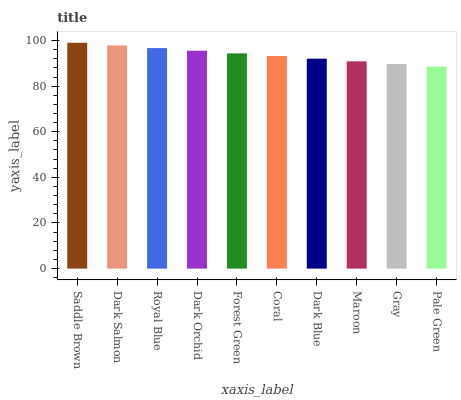Is Pale Green the minimum?
Answer yes or no. Yes. Is Saddle Brown the maximum?
Answer yes or no. Yes. Is Dark Salmon the minimum?
Answer yes or no. No. Is Dark Salmon the maximum?
Answer yes or no. No. Is Saddle Brown greater than Dark Salmon?
Answer yes or no. Yes. Is Dark Salmon less than Saddle Brown?
Answer yes or no. Yes. Is Dark Salmon greater than Saddle Brown?
Answer yes or no. No. Is Saddle Brown less than Dark Salmon?
Answer yes or no. No. Is Forest Green the high median?
Answer yes or no. Yes. Is Coral the low median?
Answer yes or no. Yes. Is Royal Blue the high median?
Answer yes or no. No. Is Royal Blue the low median?
Answer yes or no. No. 